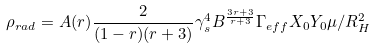<formula> <loc_0><loc_0><loc_500><loc_500>\rho _ { r a d } = A ( r ) \frac { 2 } { ( 1 - r ) ( r + 3 ) } \gamma _ { s } ^ { 4 } B ^ { \frac { 3 r + 3 } { r + 3 } } \Gamma _ { e f f } X _ { 0 } Y _ { 0 } \mu / R ^ { 2 } _ { H }</formula> 